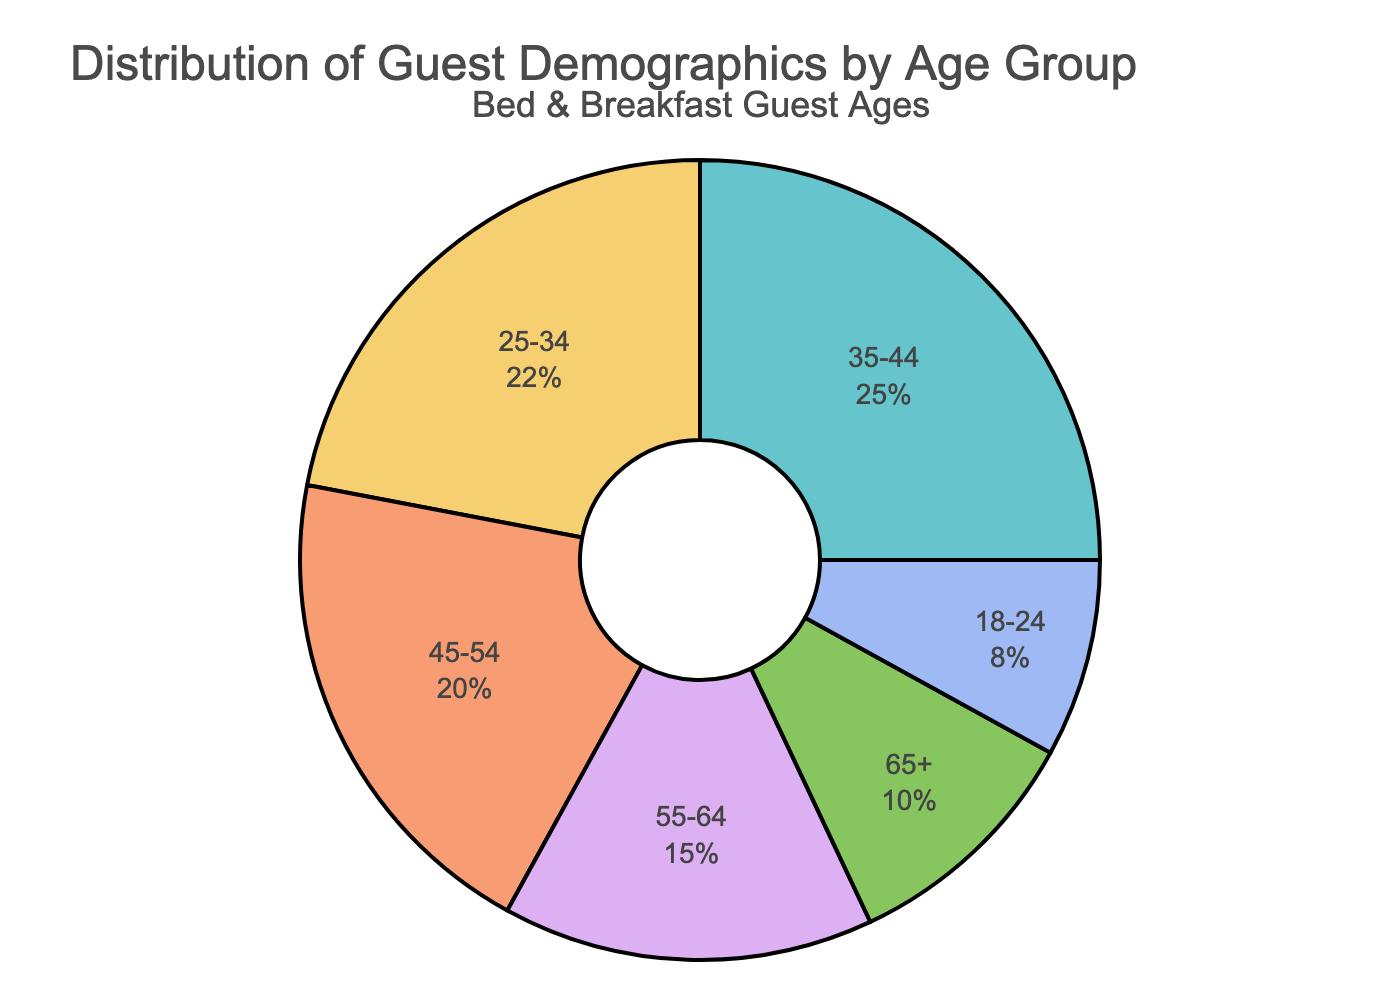Which age group has the highest percentage of guests? By looking at the pie chart, the slice representing the age group with the highest percentage is the largest slice. This slice is labeled "35-44".
Answer: 35-44 What is the combined percentage of guests aged 25-34 and 35-44? To find the combined percentage, add the percentages for those age groups: 22% (25-34) + 25% (35-44) = 47%.
Answer: 47% Is the percentage of guests aged 55-64 greater than the percentage of guests aged 18-24? Compare the two percentages directly from the chart: 15% (55-64) compared to 8% (18-24). Since 15% is greater than 8%, the percentage of guests aged 55-64 is indeed greater.
Answer: Yes What is the difference in percentage between the 35-44 age group and the 65+ age group? Subtract the percentage of the 65+ age group from the percentage of the 35-44 age group: 25% (35-44) - 10% (65+) = 15%.
Answer: 15% Which age group has the smallest representation in the distribution? Looking at the sections of the pie chart, the smallest slice is labeled "18-24".
Answer: 18-24 How many age groups represent at least 20% of the guests? From the pie chart, identify the slices with percentages at least 20%: 35-44 (25%), 25-34 (22%), and 45-54 (20%). This gives 3 age groups.
Answer: 3 If you combined the percentage of guests aged under 35, what would be the total percentage? Add the percentages of the age groups under 35: 8% (18-24) + 22% (25-34) = 30%.
Answer: 30% Compared to the 55-64 age group, how much larger in percentage is the 35-44 age group? Subtract the percentage of the 55-64 age group from the percentage of the 35-44 age group: 25% (35-44) - 15% (55-64) = 10%.
Answer: 10% Which group represents exactly twice the percentage of guests as the 18-24 age group? The 18-24 age group is 8%. Twice this percentage is 16%. The closest group to this value is 15% (55-64), but it's not exactly twice. Therefore, there is no group representing exactly twice the percentage.
Answer: None 